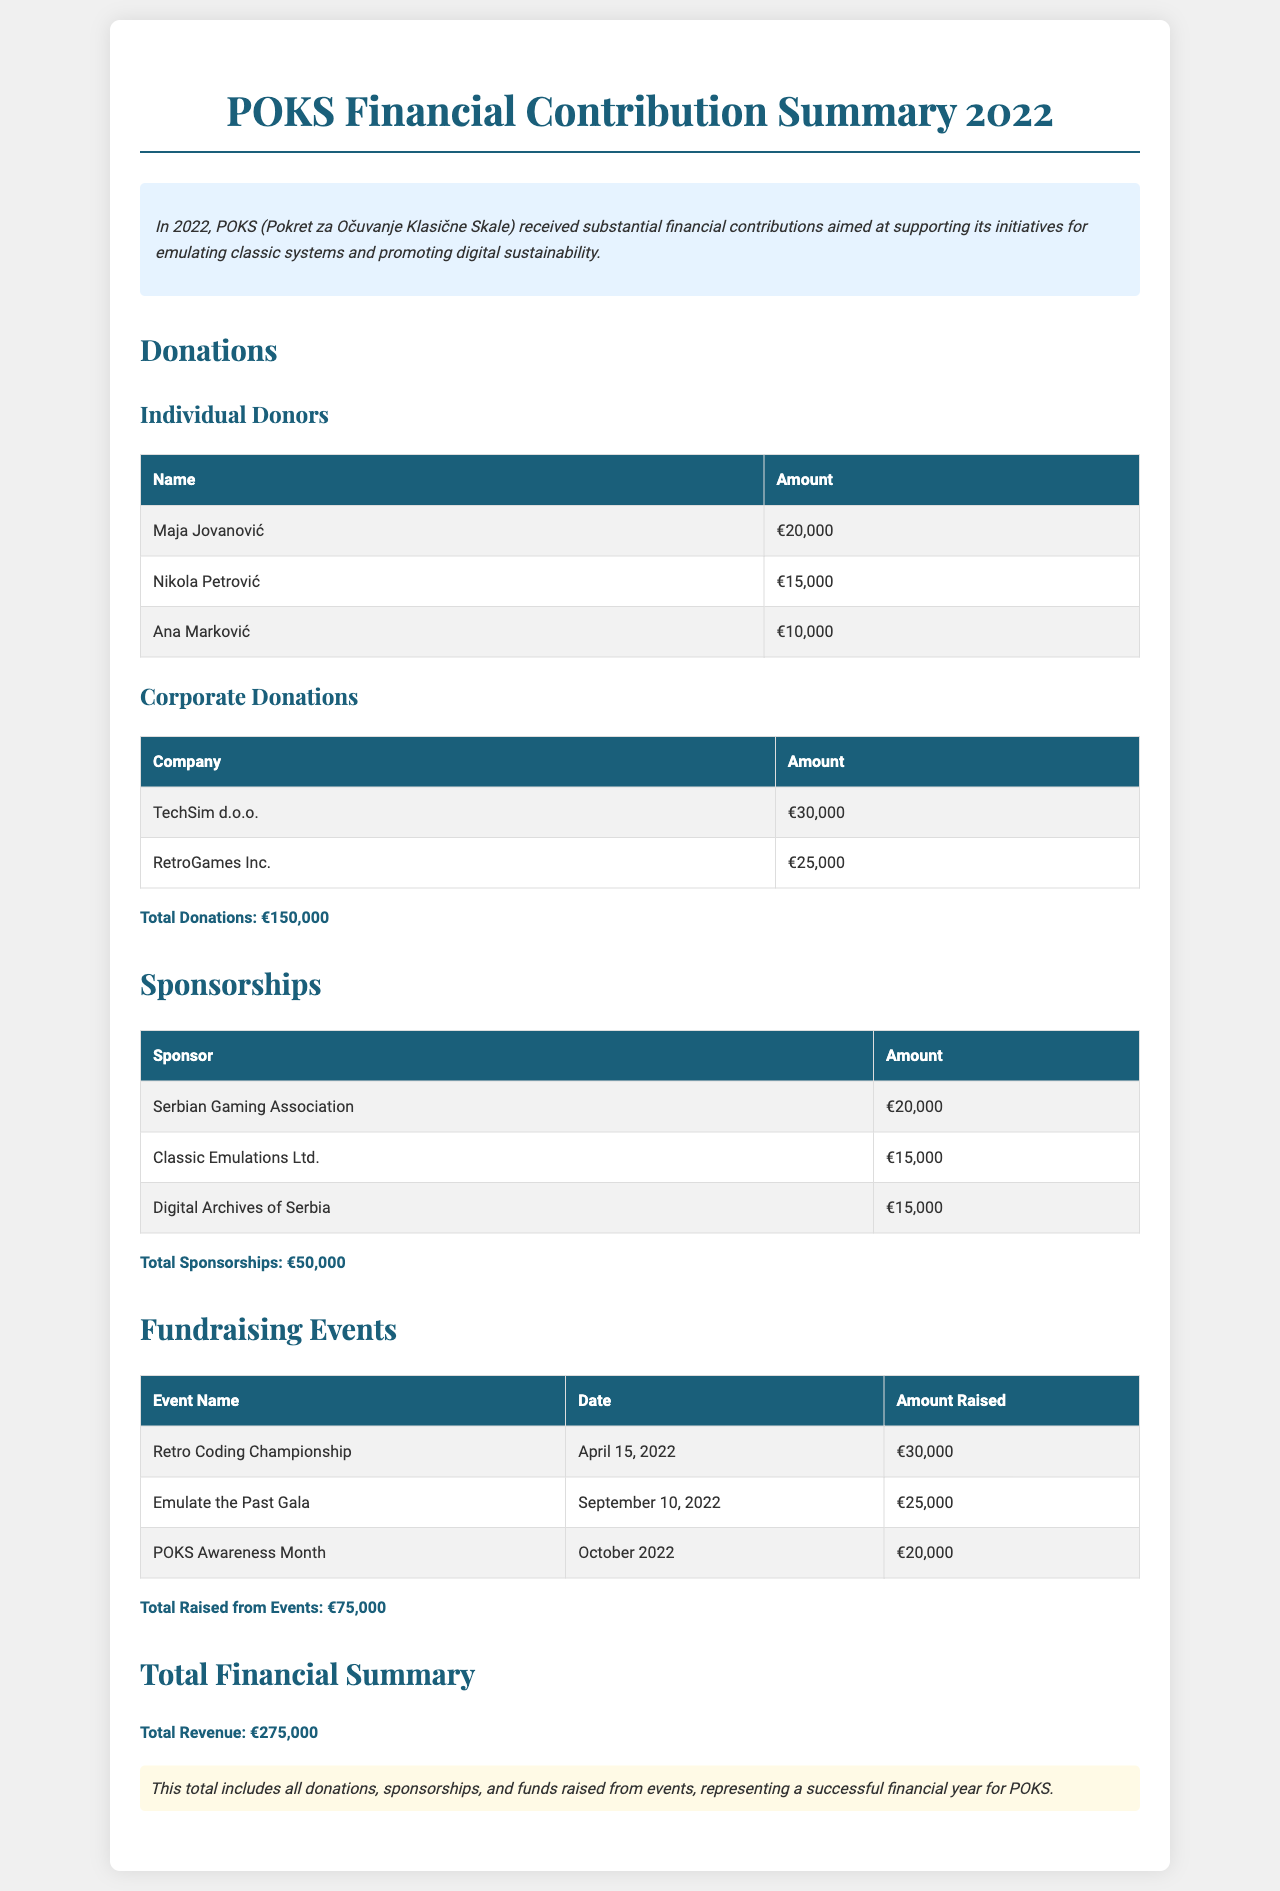What is the total donations amount? The total amount for donations is provided in the summary of the donations section and is €150,000.
Answer: €150,000 Who donated the highest amount? The individual donor with the highest contribution is mentioned in the donations table, which is Maja Jovanović with €20,000.
Answer: Maja Jovanović What is the date of the Retro Coding Championship event? The date for the Retro Coding Championship is provided in the fundraising events section, listed as April 15, 2022.
Answer: April 15, 2022 How much was raised during POKS Awareness Month? The amount raised from the fundraising event named POKS Awareness Month is found in the events table, which is €20,000.
Answer: €20,000 What was the total sponsorship amount? The total amount for sponsorships is summarized at the end of the sponsorships section, which is €50,000.
Answer: €50,000 Which corporate donor contributed the most? The highest corporate donation is detailed in the corporate donations table, which is from TechSim d.o.o. with €30,000.
Answer: TechSim d.o.o What is the total revenue reported for POKS in 2022? The total revenue is summarized at the end of the document, calculated as the sum of donations, sponsorships, and fundraising events, totaling €275,000.
Answer: €275,000 Who is a sponsor associated with Classic Emulations Ltd.? The sponsorship section lists Classic Emulations Ltd. as a sponsor along with the amount they donated, which is €15,000.
Answer: Classic Emulations Ltd 